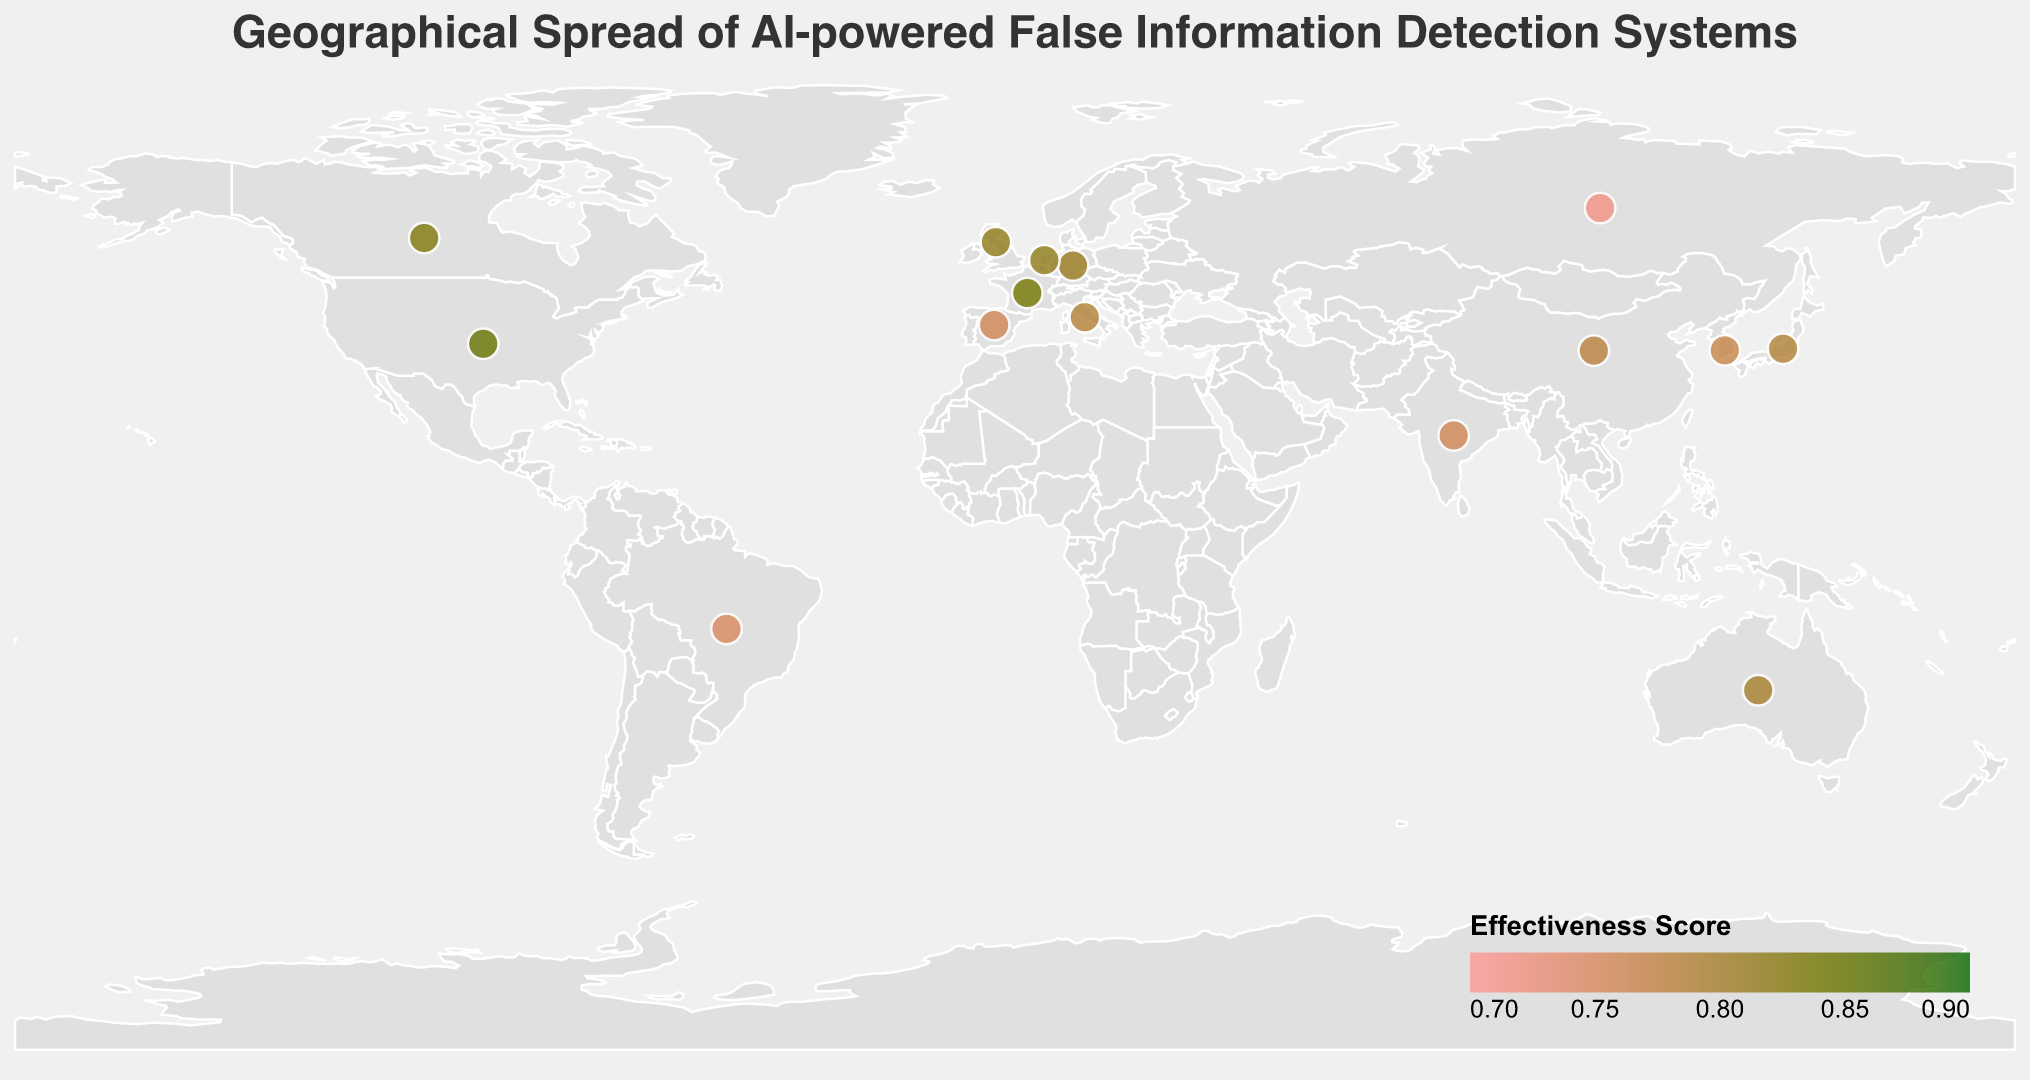Which country has the AI system with the highest effectiveness score? Look at the color legend and identify the darkest green circle on the map, which corresponds to the highest effectiveness score. The tooltip indicates it's the United States with "DeepDetect" having a score of 0.85.
Answer: United States What is the title of the figure? The title is displayed at the top of the figure. It states: "Geographical Spread of AI-powered False Information Detection Systems".
Answer: Geographical Spread of AI-powered False Information Detection Systems How many countries have deployed their AI systems in 2019? Identify the deployment year from the tooltips and count the circles associated with the year 2019. The countries are the United States, Germany, Canada, South Korea, and the Netherlands.
Answer: 5 Which AI system was deployed the most recently? Check the deployment year for each data point and find the latest year. The most recent year is 2021, and the corresponding systems are "Satyamev" in India, "VeridadeAI" in Brazil, and "DetectorVerdad" in Spain.
Answer: Satyamev, VeridadeAI, DetectorVerdad Which country achieved the lowest effectiveness score, and what was the score? Inspect the tooltip data to find the lowest effectiveness score. It is 0.72, and the AI system is "Pravda AI" in Russia.
Answer: Russia, 0.72 What is the average effectiveness score of AI systems deployed in 2020? Identify the effectiveness scores for AI systems deployed in 2020 (0.78 in China, 0.72 in Russia, 0.80 in Australia, and 0.79 in Italy). Calculate the average: (0.78 + 0.72 + 0.80 + 0.79) / 4 = 3.09 / 4 = 0.7725.
Answer: 0.7725 Which country in Europe has the highest effectiveness score? Refer to the European countries and their effectiveness scores. France, with "VéritéScan" having a score of 0.84, is the highest in Europe.
Answer: France Compare the effectiveness scores of AI systems between Canada and Australia. Which one is higher? Hover over the circles for Canada and Australia and note their effectiveness scores. Canada's "VeracityNet" has a score of 0.83, while Australia's "FalseFlag" has a score of 0.80. Therefore, Canada has a higher effectiveness score.
Answer: Canada How many countries have an AI effectiveness score above 0.80? Evaluate each country's effectiveness score and count those that are above 0.80. These countries are the United States, the United Kingdom, Germany, Canada, France, and the Netherlands.
Answer: 6 Which AI systems were deployed in the same year and have the same effectiveness score? Check the deployment year and effectiveness score for each system. FactCheck AI (United Kingdom) and WaarheidsAI (Netherlands) were both deployed in 2019, each with an effectiveness score of 0.82.
Answer: FactCheck AI and WaarheidsAI 